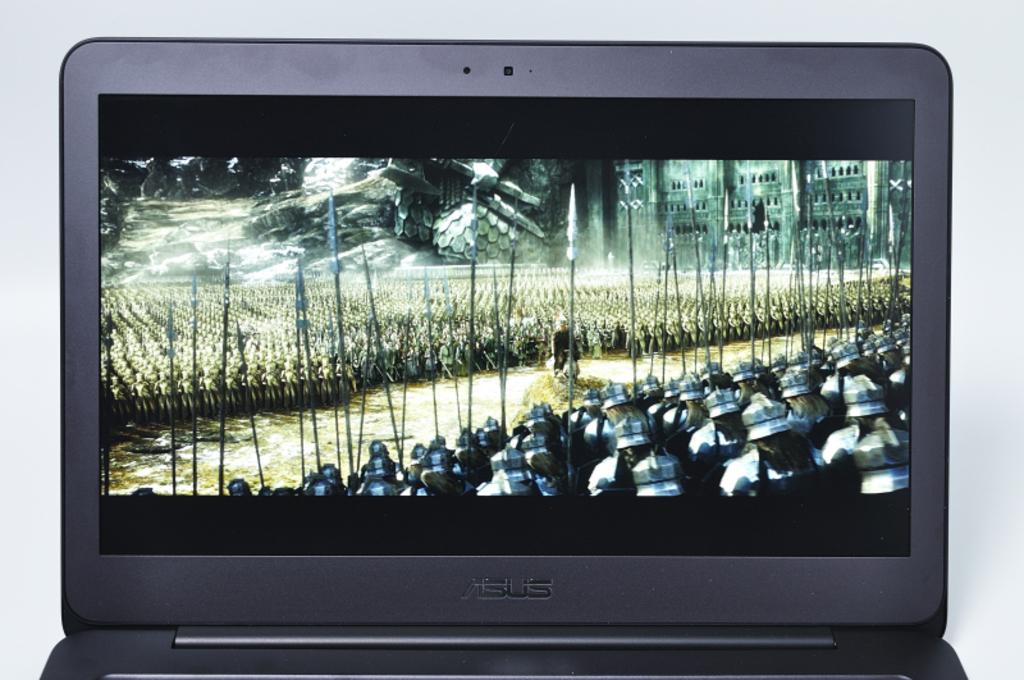Provide a one-sentence caption for the provided image. an asus laptop with a bunch of warriors on the screen. 